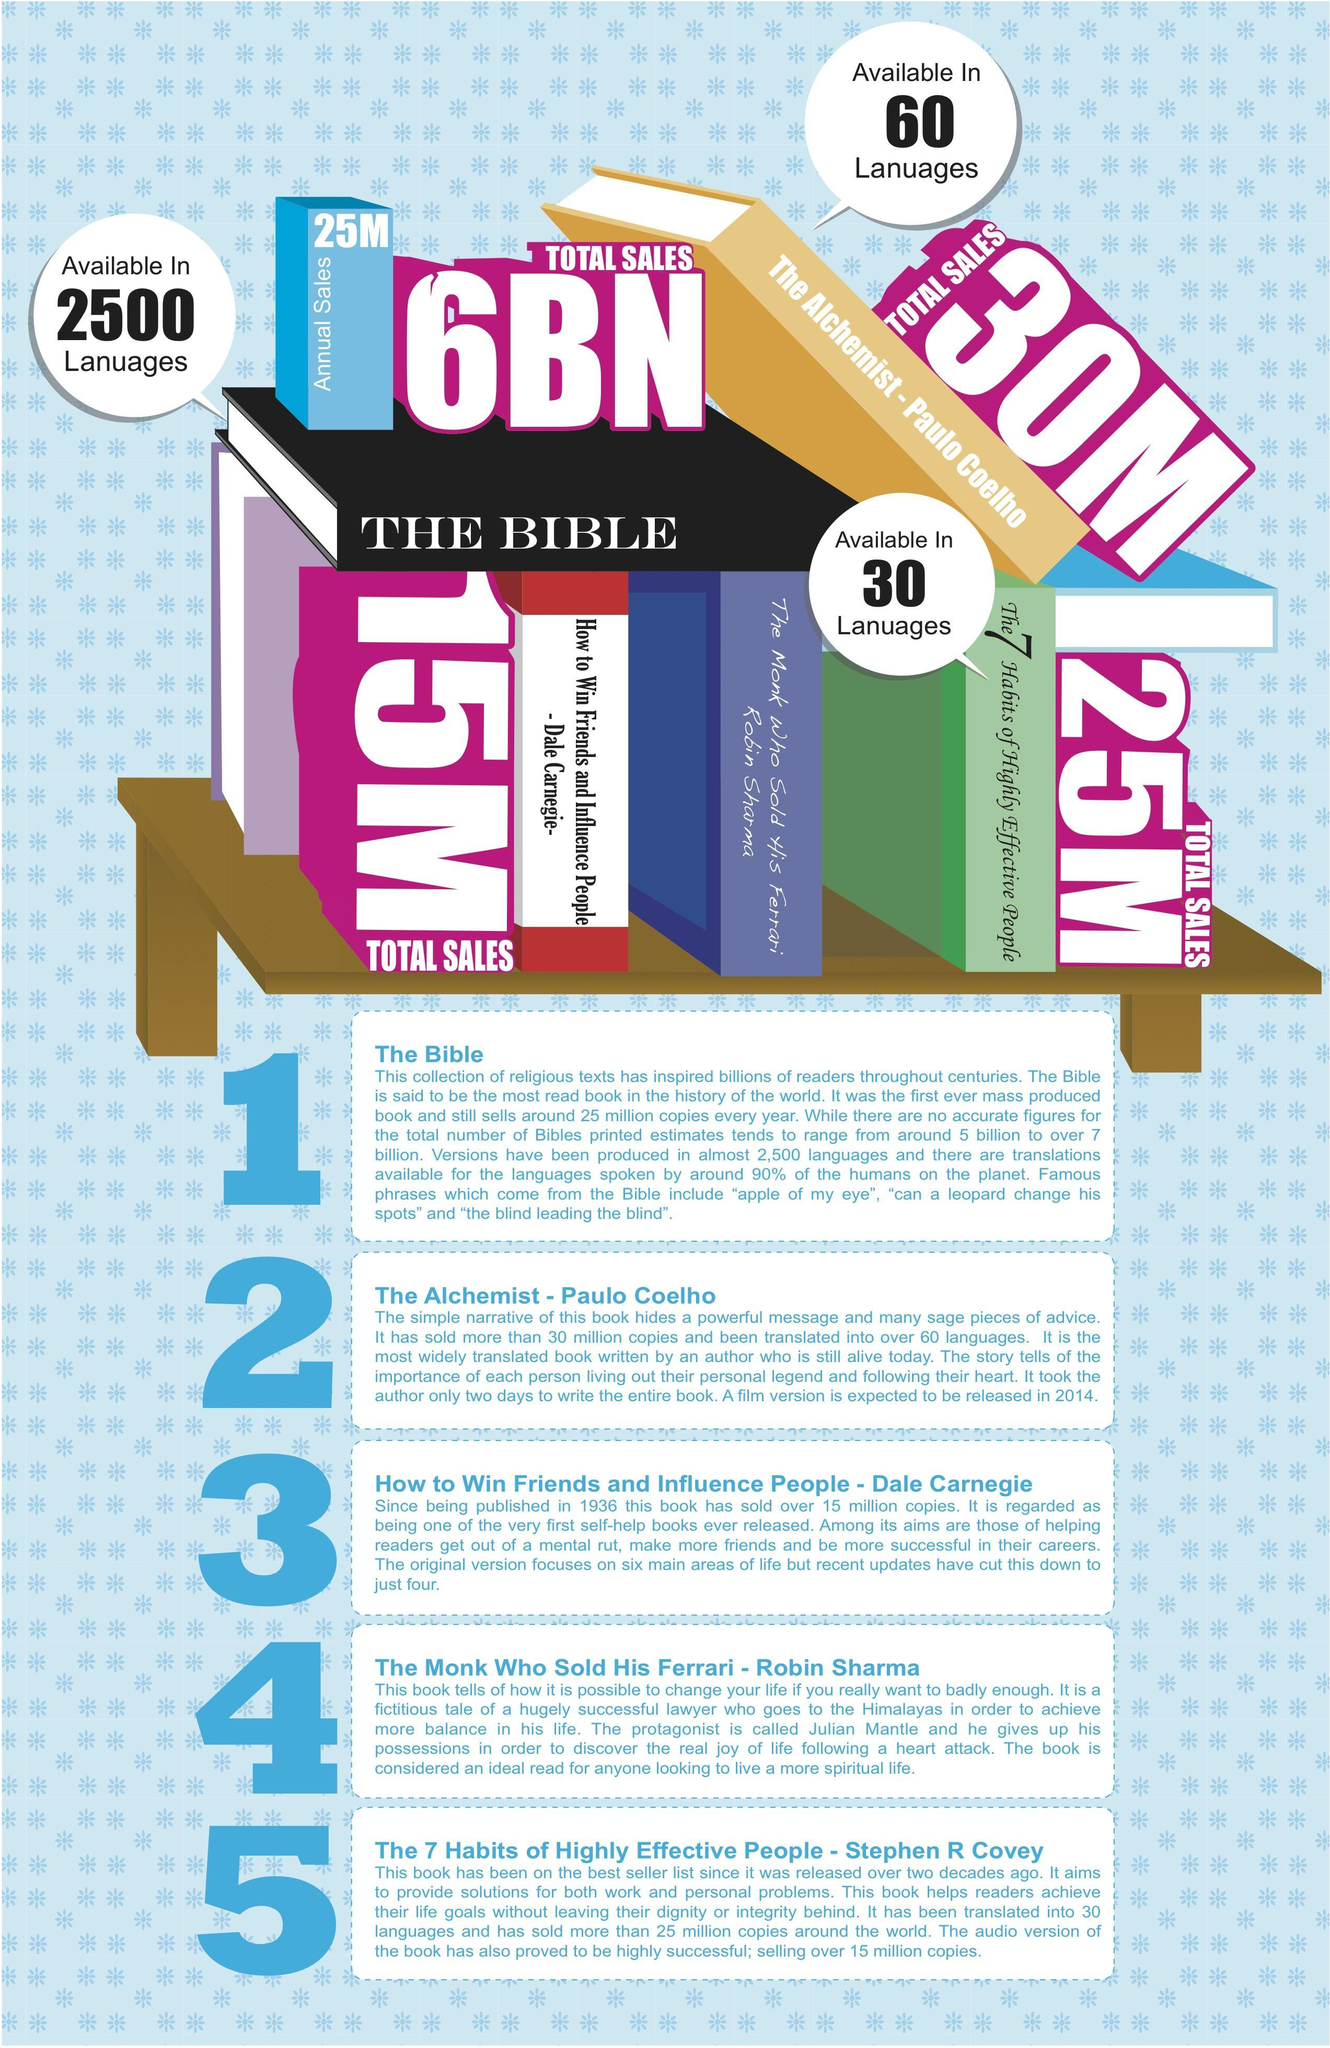Which is the most sold book?
Answer the question with a short phrase. THE BIBLE In how many languages are the Alchemist available? 60 